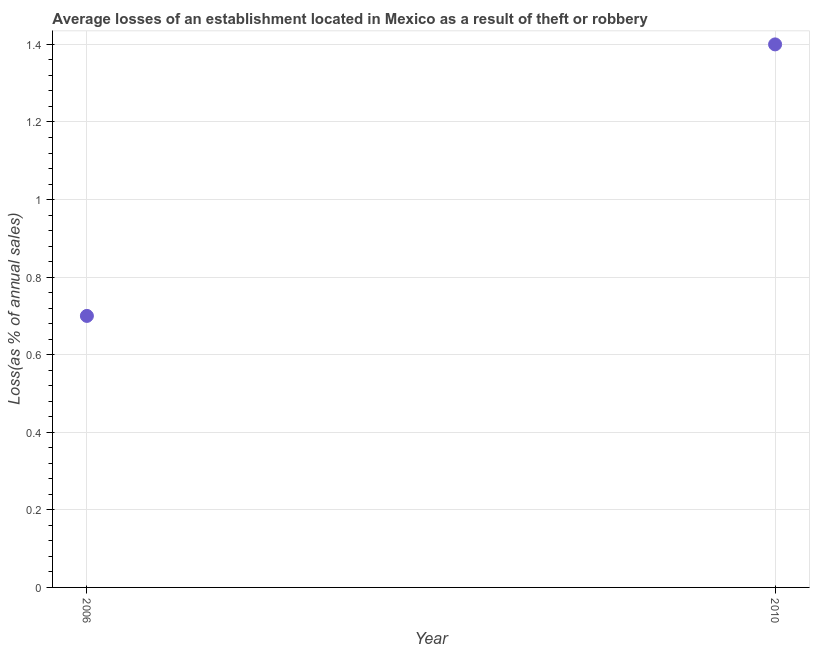What is the sum of the losses due to theft?
Give a very brief answer. 2.1. What is the average losses due to theft per year?
Offer a terse response. 1.05. What is the median losses due to theft?
Your response must be concise. 1.05. In how many years, is the losses due to theft greater than 0.12 %?
Give a very brief answer. 2. Do a majority of the years between 2006 and 2010 (inclusive) have losses due to theft greater than 0.6000000000000001 %?
Your response must be concise. Yes. What is the ratio of the losses due to theft in 2006 to that in 2010?
Give a very brief answer. 0.5. Is the losses due to theft in 2006 less than that in 2010?
Offer a very short reply. Yes. Does the losses due to theft monotonically increase over the years?
Your response must be concise. Yes. How many dotlines are there?
Make the answer very short. 1. How many years are there in the graph?
Offer a terse response. 2. What is the difference between two consecutive major ticks on the Y-axis?
Provide a succinct answer. 0.2. What is the title of the graph?
Offer a terse response. Average losses of an establishment located in Mexico as a result of theft or robbery. What is the label or title of the Y-axis?
Provide a succinct answer. Loss(as % of annual sales). What is the Loss(as % of annual sales) in 2006?
Make the answer very short. 0.7. What is the difference between the Loss(as % of annual sales) in 2006 and 2010?
Offer a very short reply. -0.7. 